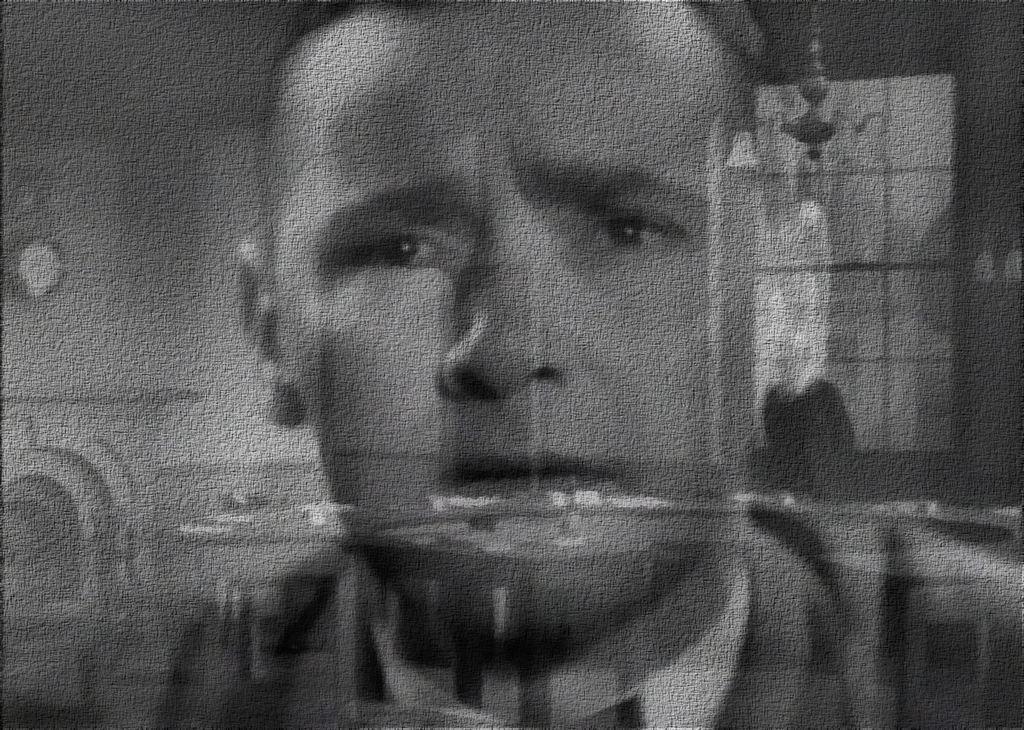How would you summarize this image in a sentence or two? This is a black and white image. In this image we can see the face of a person. On the backside we can see a wall and a window. 